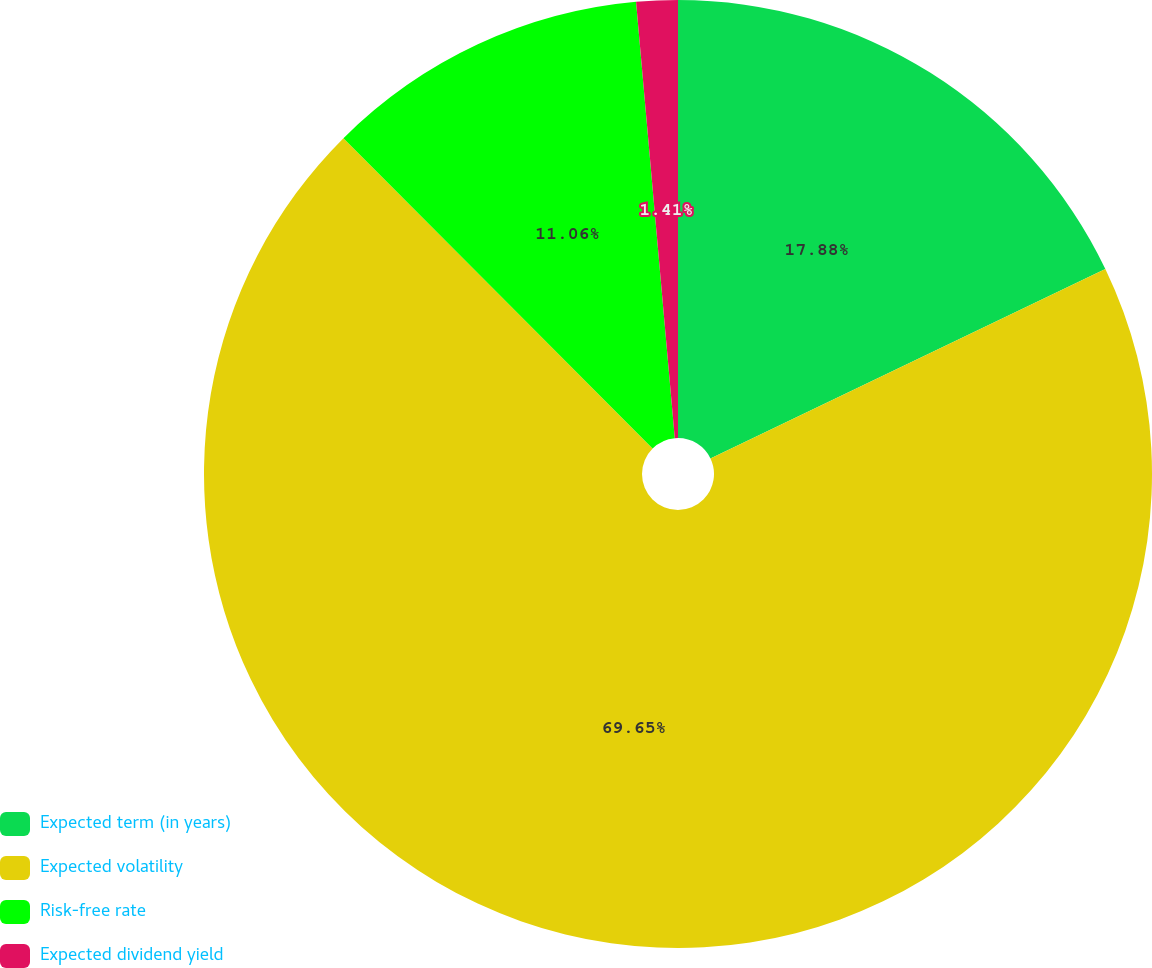Convert chart to OTSL. <chart><loc_0><loc_0><loc_500><loc_500><pie_chart><fcel>Expected term (in years)<fcel>Expected volatility<fcel>Risk-free rate<fcel>Expected dividend yield<nl><fcel>17.88%<fcel>69.65%<fcel>11.06%<fcel>1.41%<nl></chart> 